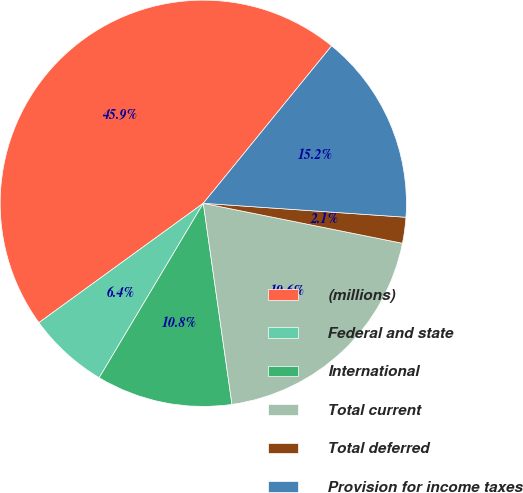Convert chart to OTSL. <chart><loc_0><loc_0><loc_500><loc_500><pie_chart><fcel>(millions)<fcel>Federal and state<fcel>International<fcel>Total current<fcel>Total deferred<fcel>Provision for income taxes<nl><fcel>45.88%<fcel>6.44%<fcel>10.82%<fcel>19.59%<fcel>2.06%<fcel>15.21%<nl></chart> 